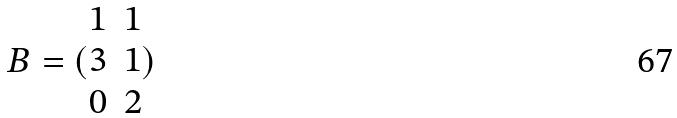<formula> <loc_0><loc_0><loc_500><loc_500>B = ( \begin{matrix} 1 & 1 \\ 3 & 1 \\ 0 & 2 \end{matrix} )</formula> 